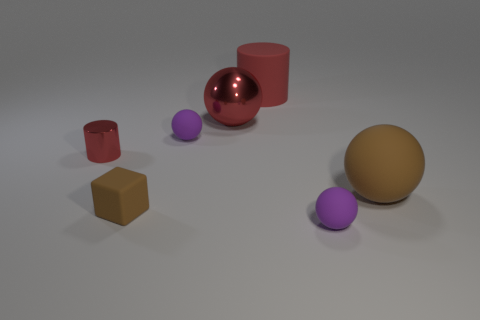Add 1 big brown matte balls. How many objects exist? 8 Subtract all spheres. How many objects are left? 3 Subtract all tiny brown things. Subtract all yellow cubes. How many objects are left? 6 Add 6 tiny metallic objects. How many tiny metallic objects are left? 7 Add 1 small purple spheres. How many small purple spheres exist? 3 Subtract 0 blue blocks. How many objects are left? 7 